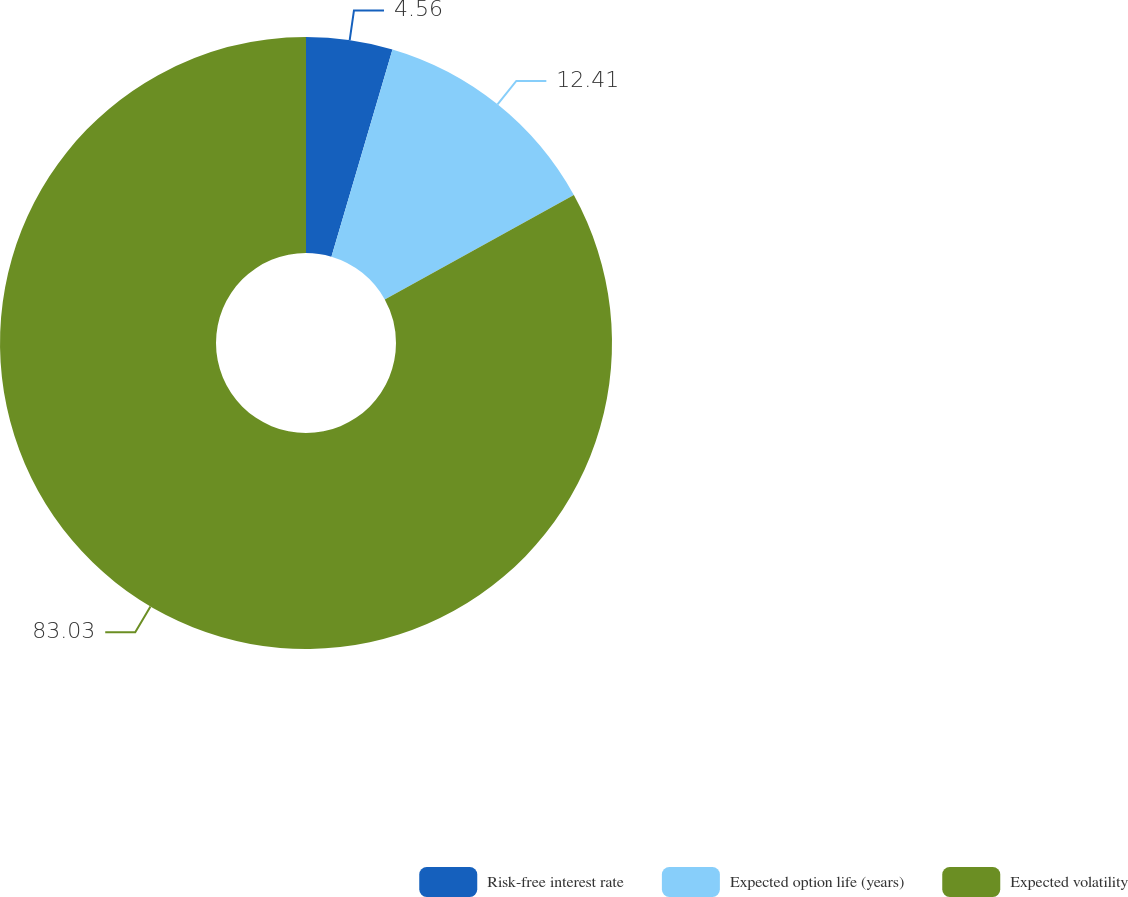Convert chart. <chart><loc_0><loc_0><loc_500><loc_500><pie_chart><fcel>Risk-free interest rate<fcel>Expected option life (years)<fcel>Expected volatility<nl><fcel>4.56%<fcel>12.41%<fcel>83.03%<nl></chart> 